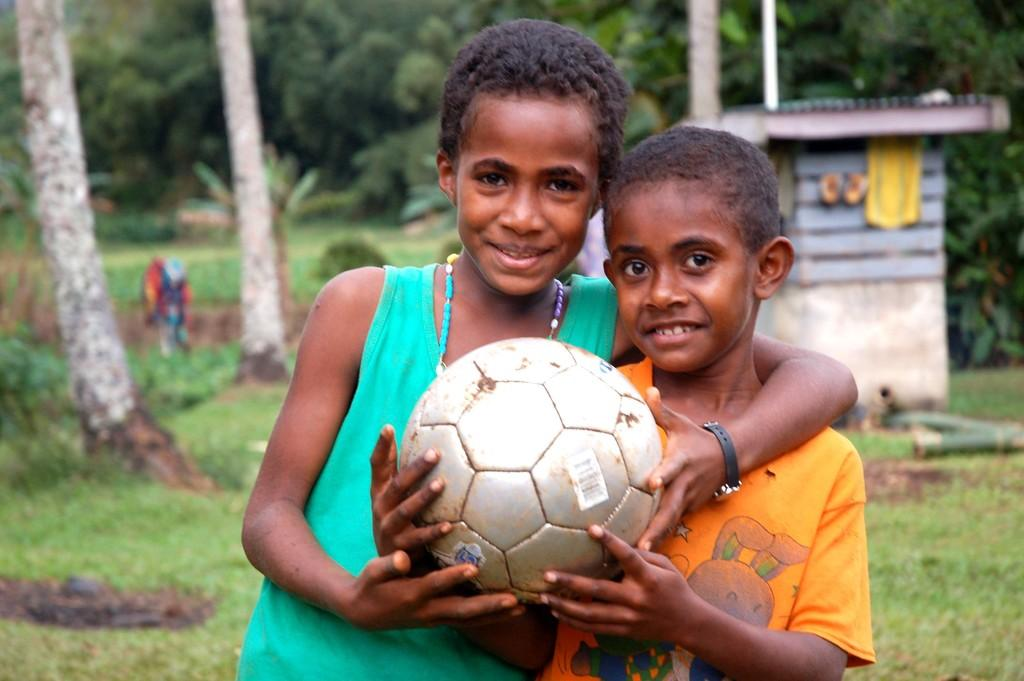How many kids are in the image? There are two kids in the image. What are the kids holding in the image? The kids are holding a ball. What can be seen in the background of the image? There are trees in the background of the image. What type of spy equipment can be seen in the hands of the kids in the image? There is no spy equipment visible in the hands of the kids in the image; they are holding a ball. 